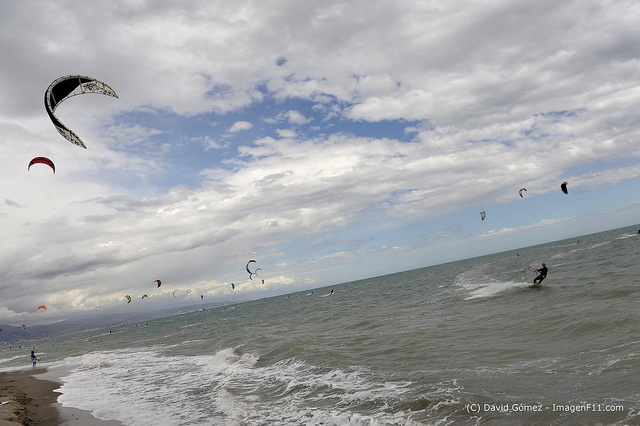Describe the objects in this image and their specific colors. I can see kite in darkgray, black, gray, and lightgray tones, kite in darkgray, gray, and brown tones, kite in darkgray, maroon, lightgray, and black tones, people in darkgray, black, gray, and maroon tones, and people in darkgray, gray, black, and navy tones in this image. 